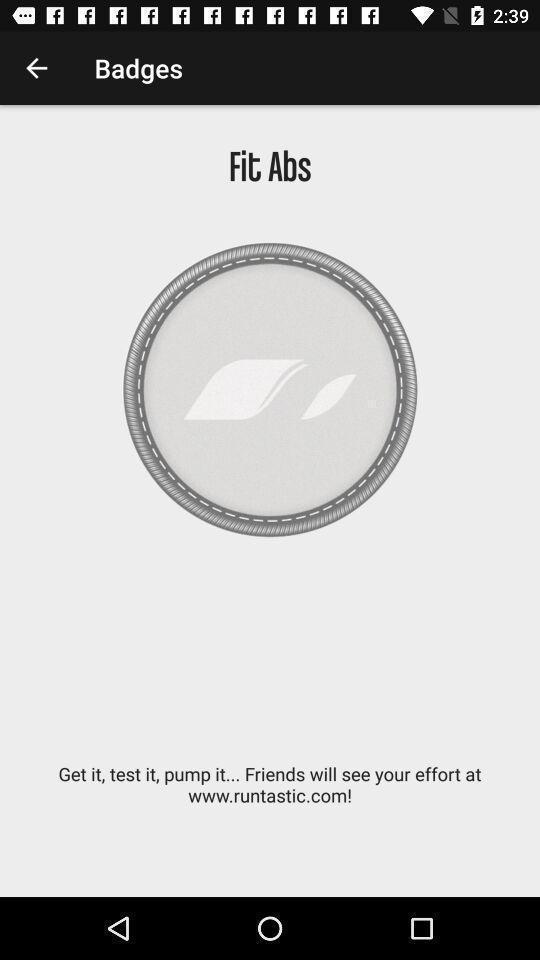What is the overall content of this screenshot? Page showing information about fit abs. 